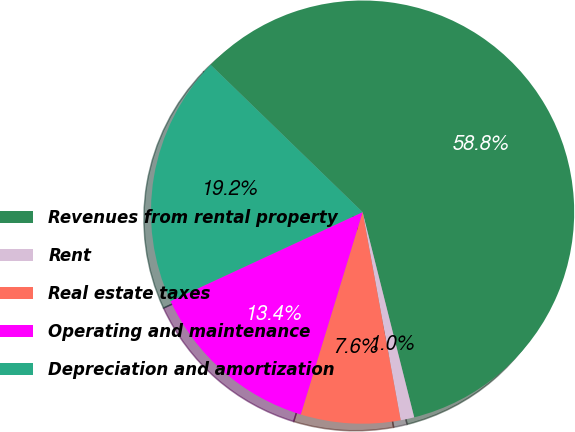<chart> <loc_0><loc_0><loc_500><loc_500><pie_chart><fcel>Revenues from rental property<fcel>Rent<fcel>Real estate taxes<fcel>Operating and maintenance<fcel>Depreciation and amortization<nl><fcel>58.83%<fcel>1.04%<fcel>7.6%<fcel>13.38%<fcel>19.16%<nl></chart> 